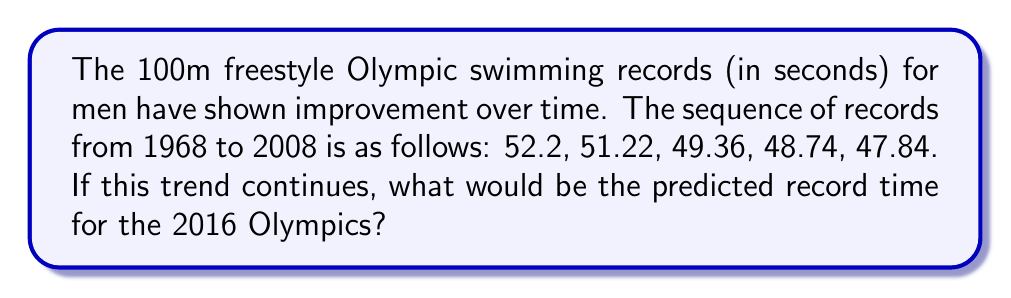Help me with this question. To solve this problem, we'll follow these steps:

1. Calculate the differences between consecutive records:
   $52.2 - 51.22 = 0.98$
   $51.22 - 49.36 = 1.86$
   $49.36 - 48.74 = 0.62$
   $48.74 - 47.84 = 0.9$

2. Calculate the average improvement:
   $\frac{0.98 + 1.86 + 0.62 + 0.9}{4} = 1.09$ seconds

3. Determine the time interval between records:
   1968 to 1972: 4 years
   1972 to 1976: 4 years
   1976 to 1988: 12 years
   1988 to 2008: 20 years

4. Calculate the average time interval:
   $\frac{4 + 4 + 12 + 20}{4} = 10$ years

5. Determine the number of intervals between 2008 and 2016:
   $\frac{2016 - 2008}{10} = 0.8$ intervals

6. Calculate the predicted improvement:
   $0.8 \times 1.09 = 0.872$ seconds

7. Subtract the improvement from the 2008 record:
   $47.84 - 0.872 = 46.968$ seconds

Therefore, the predicted record time for the 2016 Olympics would be approximately 46.97 seconds.
Answer: 46.97 seconds 